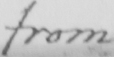Transcribe the text shown in this historical manuscript line. from 